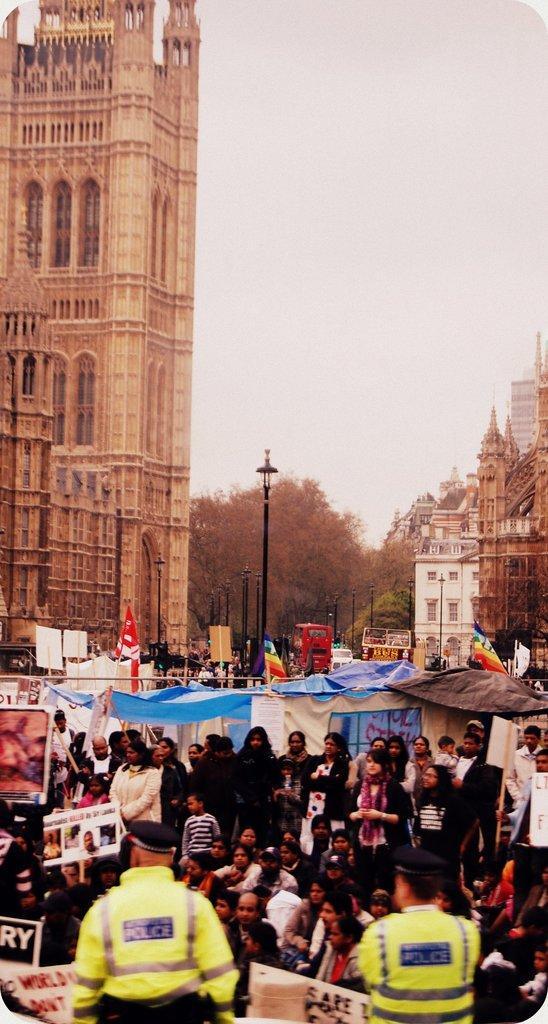How would you summarize this image in a sentence or two? There are people holding posters and cops in the foreground area of the image, there are vehicles, poles, trees, buildings and the sky in the background. 